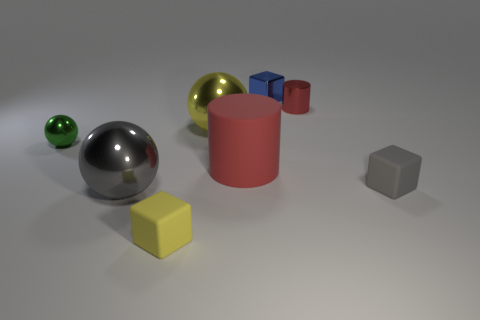The other tiny thing that is the same material as the small gray object is what color?
Your response must be concise. Yellow. How big is the block to the left of the blue metal cube?
Give a very brief answer. Small. Are there fewer big matte cylinders to the right of the gray rubber thing than blue matte things?
Provide a short and direct response. No. Do the large rubber object and the tiny sphere have the same color?
Keep it short and to the point. No. Is there anything else that is the same shape as the green metallic thing?
Give a very brief answer. Yes. Is the number of big matte cylinders less than the number of brown rubber cubes?
Your answer should be very brief. No. There is a tiny object on the left side of the large shiny thing that is in front of the gray cube; what is its color?
Your response must be concise. Green. What material is the cube behind the green metallic sphere that is behind the small rubber object that is behind the small yellow block?
Your answer should be very brief. Metal. There is a yellow shiny ball that is right of the gray metal ball; does it have the same size as the tiny sphere?
Provide a short and direct response. No. What material is the big thing on the right side of the yellow ball?
Provide a short and direct response. Rubber. 